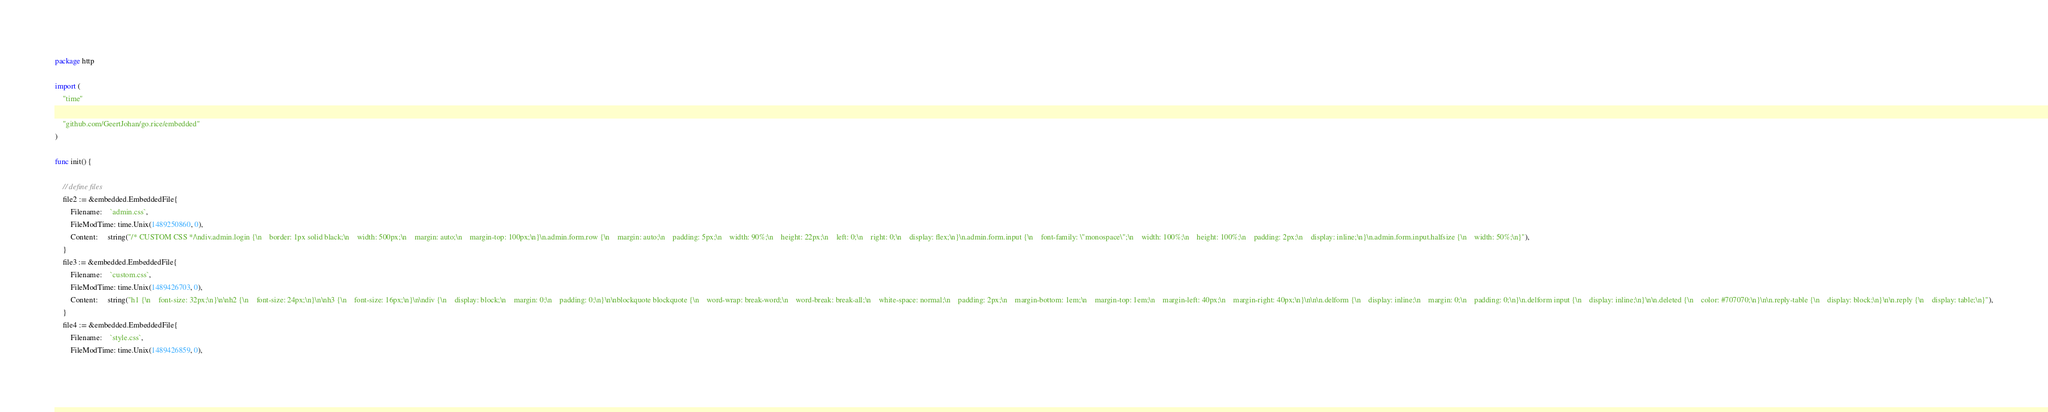<code> <loc_0><loc_0><loc_500><loc_500><_Go_>package http

import (
	"time"

	"github.com/GeertJohan/go.rice/embedded"
)

func init() {

	// define files
	file2 := &embedded.EmbeddedFile{
		Filename:    `admin.css`,
		FileModTime: time.Unix(1489250860, 0),
		Content:     string("/* CUSTOM CSS */\ndiv.admin.login {\n    border: 1px solid black;\n    width: 500px;\n    margin: auto;\n    margin-top: 100px;\n}\n.admin.form.row {\n    margin: auto;\n    padding: 5px;\n    width: 90%;\n    height: 22px;\n    left: 0;\n    right: 0;\n    display: flex;\n}\n.admin.form.input {\n    font-family: \"monospace\";\n    width: 100%;\n    height: 100%;\n    padding: 2px;\n    display: inline;\n}\n.admin.form.input.halfsize {\n    width: 50%;\n}"),
	}
	file3 := &embedded.EmbeddedFile{
		Filename:    `custom.css`,
		FileModTime: time.Unix(1489426703, 0),
		Content:     string("h1 {\n    font-size: 32px;\n}\n\nh2 {\n    font-size: 24px;\n}\n\nh3 {\n    font-size: 16px;\n}\n\ndiv {\n    display: block;\n    margin: 0;\n    padding: 0;\n}\n\nblockquote blockquote {\n    word-wrap: break-word;\n    word-break: break-all;\n    white-space: normal;\n    padding: 2px;\n    margin-bottom: 1em;\n    margin-top: 1em;\n    margin-left: 40px;\n    margin-right: 40px;\n}\n\n\n.delform {\n    display: inline;\n    margin: 0;\n    padding: 0;\n}\n.delform input {\n    display: inline;\n}\n\n.deleted {\n    color: #707070;\n}\n\n.reply-table {\n    display: block;\n}\n\n.reply {\n    display: table;\n}"),
	}
	file4 := &embedded.EmbeddedFile{
		Filename:    `style.css`,
		FileModTime: time.Unix(1489426859, 0),</code> 